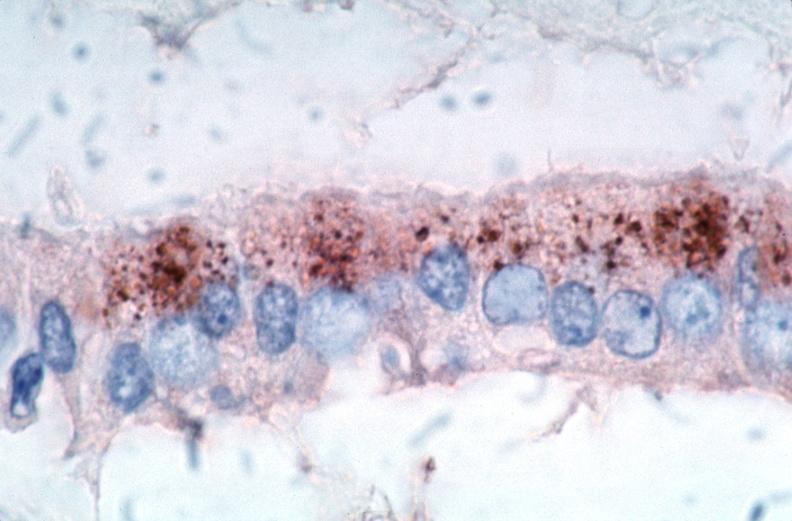s rocky mountain spotted fever, immunoperoxidase staining vessels for rickettsia rickettsii?
Answer the question using a single word or phrase. Yes 